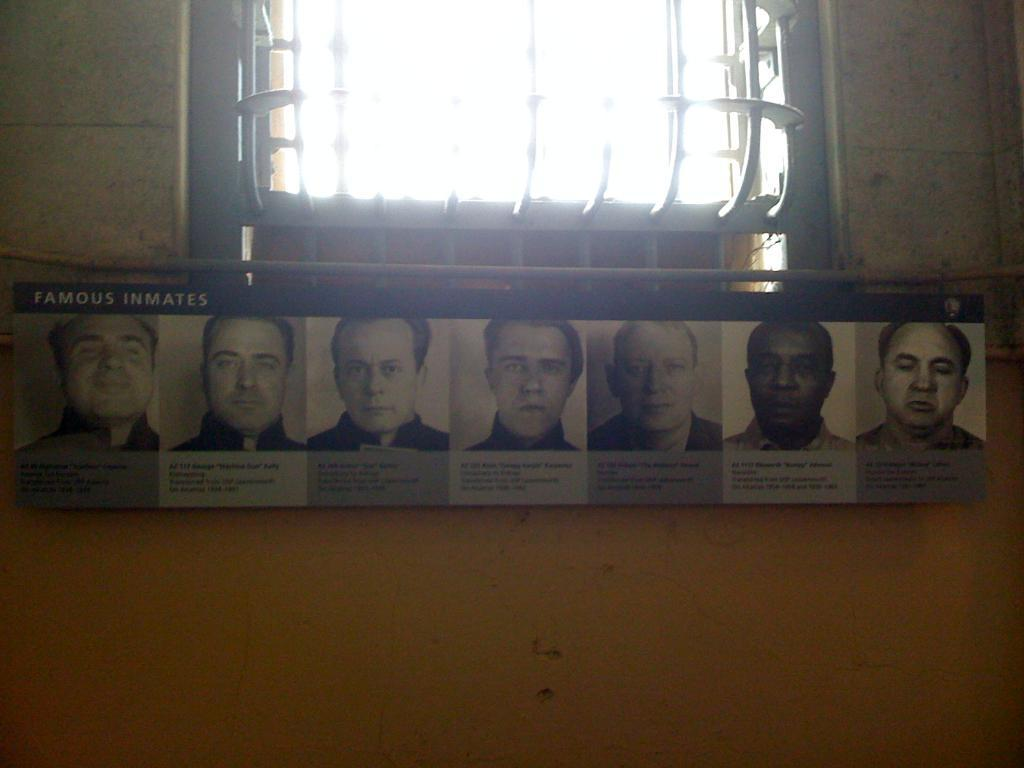Where was the image taken? The image was taken in a room. What can be seen in the front of the image? There is a light in the front of the image. What is on the wall in the image? There is a wall with a banner in the image. How many fingers can be seen on the banner in the image? There are no fingers visible on the banner in the image. What type of room is depicted in the image? The type of room cannot be determined from the image alone. 